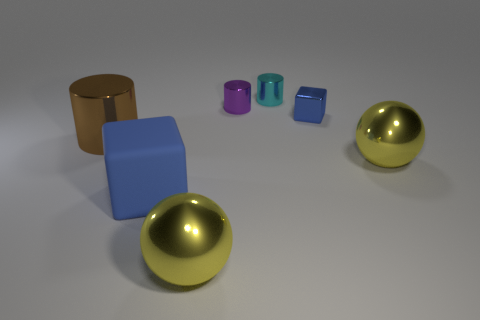Can you describe the surface the objects are resting on? The objects are resting on a flat, matte gray surface that gives the impression of an infinite expanse due to the lack of visible boundaries. 